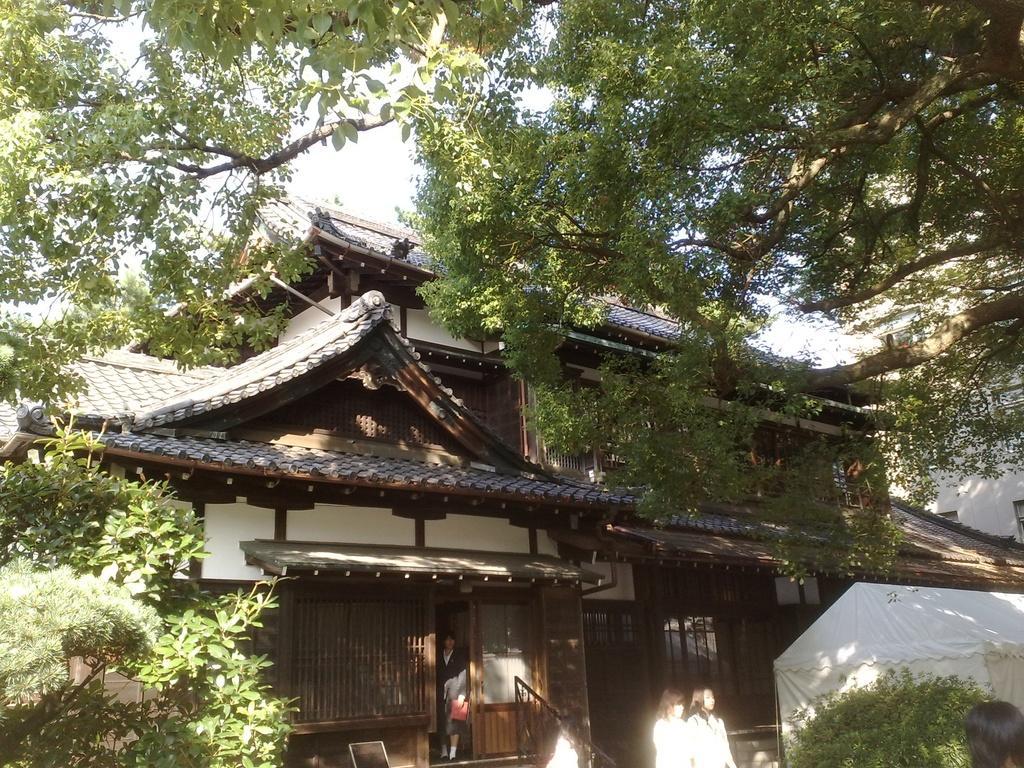How would you summarize this image in a sentence or two? In this image I can see a house and in front of house I can see trees and persons and the sky visible at the top. 